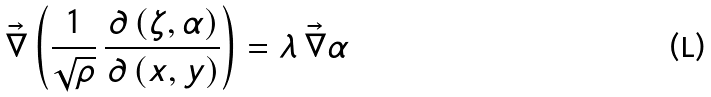<formula> <loc_0><loc_0><loc_500><loc_500>\vec { \nabla } \left ( \frac { 1 } { \sqrt { \rho } } \, \frac { \partial \left ( \zeta , \alpha \right ) } { \partial \left ( x , y \right ) } \right ) = \lambda \, \vec { \nabla } \alpha</formula> 